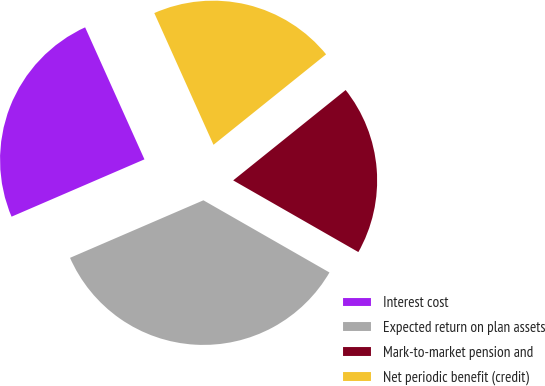Convert chart to OTSL. <chart><loc_0><loc_0><loc_500><loc_500><pie_chart><fcel>Interest cost<fcel>Expected return on plan assets<fcel>Mark-to-market pension and<fcel>Net periodic benefit (credit)<nl><fcel>24.76%<fcel>35.24%<fcel>19.05%<fcel>20.95%<nl></chart> 